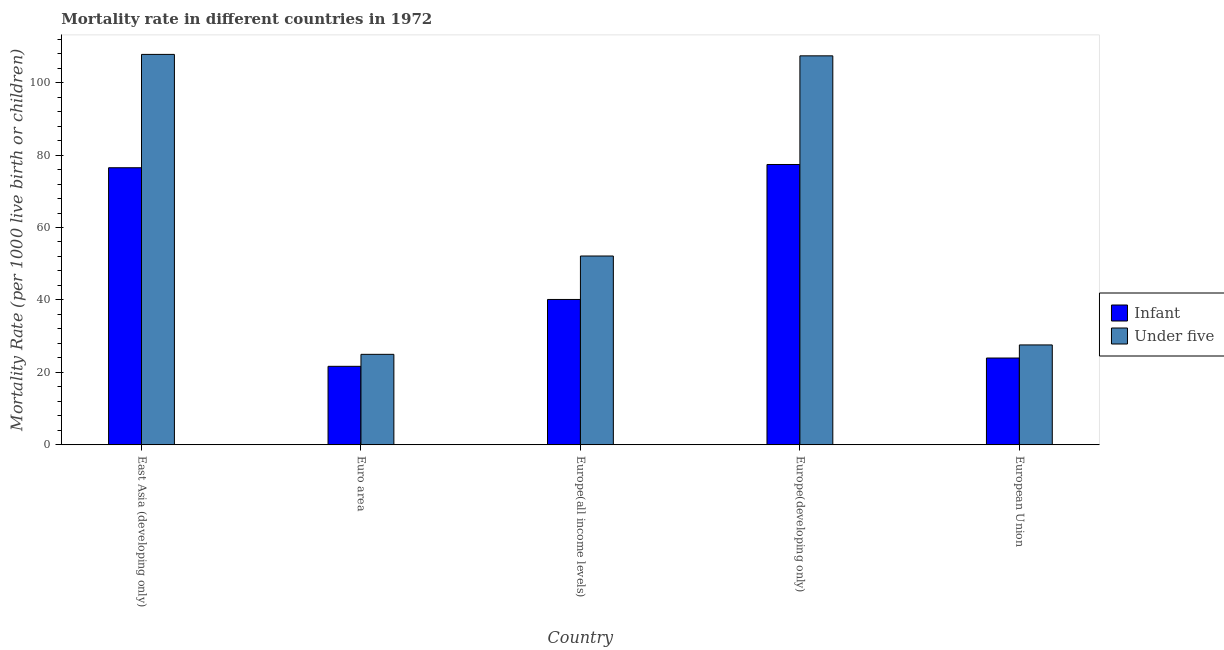How many groups of bars are there?
Offer a terse response. 5. Are the number of bars on each tick of the X-axis equal?
Provide a short and direct response. Yes. How many bars are there on the 3rd tick from the left?
Your answer should be compact. 2. What is the label of the 4th group of bars from the left?
Give a very brief answer. Europe(developing only). What is the infant mortality rate in Europe(developing only)?
Your response must be concise. 77.4. Across all countries, what is the maximum under-5 mortality rate?
Your response must be concise. 107.8. Across all countries, what is the minimum infant mortality rate?
Offer a very short reply. 21.67. In which country was the under-5 mortality rate maximum?
Offer a very short reply. East Asia (developing only). What is the total under-5 mortality rate in the graph?
Give a very brief answer. 319.88. What is the difference between the under-5 mortality rate in Euro area and that in European Union?
Your response must be concise. -2.6. What is the difference between the infant mortality rate in East Asia (developing only) and the under-5 mortality rate in Europe(developing only)?
Your response must be concise. -30.9. What is the average under-5 mortality rate per country?
Keep it short and to the point. 63.98. What is the difference between the infant mortality rate and under-5 mortality rate in East Asia (developing only)?
Offer a terse response. -31.3. What is the ratio of the under-5 mortality rate in Euro area to that in Europe(developing only)?
Your response must be concise. 0.23. Is the under-5 mortality rate in Euro area less than that in Europe(all income levels)?
Your answer should be very brief. Yes. What is the difference between the highest and the second highest under-5 mortality rate?
Make the answer very short. 0.4. What is the difference between the highest and the lowest infant mortality rate?
Make the answer very short. 55.73. Is the sum of the infant mortality rate in East Asia (developing only) and Europe(developing only) greater than the maximum under-5 mortality rate across all countries?
Your response must be concise. Yes. What does the 1st bar from the left in Europe(developing only) represents?
Your response must be concise. Infant. What does the 2nd bar from the right in Euro area represents?
Offer a terse response. Infant. How many bars are there?
Your answer should be compact. 10. Are all the bars in the graph horizontal?
Your answer should be compact. No. Are the values on the major ticks of Y-axis written in scientific E-notation?
Offer a very short reply. No. Does the graph contain any zero values?
Offer a very short reply. No. Where does the legend appear in the graph?
Ensure brevity in your answer.  Center right. How many legend labels are there?
Provide a short and direct response. 2. What is the title of the graph?
Offer a very short reply. Mortality rate in different countries in 1972. What is the label or title of the X-axis?
Provide a succinct answer. Country. What is the label or title of the Y-axis?
Your answer should be compact. Mortality Rate (per 1000 live birth or children). What is the Mortality Rate (per 1000 live birth or children) in Infant in East Asia (developing only)?
Keep it short and to the point. 76.5. What is the Mortality Rate (per 1000 live birth or children) in Under five in East Asia (developing only)?
Offer a very short reply. 107.8. What is the Mortality Rate (per 1000 live birth or children) of Infant in Euro area?
Give a very brief answer. 21.67. What is the Mortality Rate (per 1000 live birth or children) of Under five in Euro area?
Provide a succinct answer. 24.98. What is the Mortality Rate (per 1000 live birth or children) of Infant in Europe(all income levels)?
Your answer should be very brief. 40.13. What is the Mortality Rate (per 1000 live birth or children) of Under five in Europe(all income levels)?
Offer a very short reply. 52.13. What is the Mortality Rate (per 1000 live birth or children) of Infant in Europe(developing only)?
Offer a very short reply. 77.4. What is the Mortality Rate (per 1000 live birth or children) of Under five in Europe(developing only)?
Make the answer very short. 107.4. What is the Mortality Rate (per 1000 live birth or children) of Infant in European Union?
Your answer should be very brief. 23.96. What is the Mortality Rate (per 1000 live birth or children) of Under five in European Union?
Provide a succinct answer. 27.58. Across all countries, what is the maximum Mortality Rate (per 1000 live birth or children) in Infant?
Provide a short and direct response. 77.4. Across all countries, what is the maximum Mortality Rate (per 1000 live birth or children) of Under five?
Keep it short and to the point. 107.8. Across all countries, what is the minimum Mortality Rate (per 1000 live birth or children) in Infant?
Keep it short and to the point. 21.67. Across all countries, what is the minimum Mortality Rate (per 1000 live birth or children) of Under five?
Provide a short and direct response. 24.98. What is the total Mortality Rate (per 1000 live birth or children) in Infant in the graph?
Ensure brevity in your answer.  239.66. What is the total Mortality Rate (per 1000 live birth or children) of Under five in the graph?
Provide a succinct answer. 319.88. What is the difference between the Mortality Rate (per 1000 live birth or children) in Infant in East Asia (developing only) and that in Euro area?
Ensure brevity in your answer.  54.83. What is the difference between the Mortality Rate (per 1000 live birth or children) in Under five in East Asia (developing only) and that in Euro area?
Ensure brevity in your answer.  82.82. What is the difference between the Mortality Rate (per 1000 live birth or children) in Infant in East Asia (developing only) and that in Europe(all income levels)?
Your answer should be compact. 36.37. What is the difference between the Mortality Rate (per 1000 live birth or children) of Under five in East Asia (developing only) and that in Europe(all income levels)?
Provide a succinct answer. 55.67. What is the difference between the Mortality Rate (per 1000 live birth or children) of Under five in East Asia (developing only) and that in Europe(developing only)?
Ensure brevity in your answer.  0.4. What is the difference between the Mortality Rate (per 1000 live birth or children) in Infant in East Asia (developing only) and that in European Union?
Keep it short and to the point. 52.54. What is the difference between the Mortality Rate (per 1000 live birth or children) in Under five in East Asia (developing only) and that in European Union?
Offer a very short reply. 80.22. What is the difference between the Mortality Rate (per 1000 live birth or children) of Infant in Euro area and that in Europe(all income levels)?
Your answer should be compact. -18.46. What is the difference between the Mortality Rate (per 1000 live birth or children) of Under five in Euro area and that in Europe(all income levels)?
Make the answer very short. -27.15. What is the difference between the Mortality Rate (per 1000 live birth or children) of Infant in Euro area and that in Europe(developing only)?
Offer a very short reply. -55.73. What is the difference between the Mortality Rate (per 1000 live birth or children) in Under five in Euro area and that in Europe(developing only)?
Offer a very short reply. -82.42. What is the difference between the Mortality Rate (per 1000 live birth or children) of Infant in Euro area and that in European Union?
Your answer should be very brief. -2.29. What is the difference between the Mortality Rate (per 1000 live birth or children) in Under five in Euro area and that in European Union?
Offer a very short reply. -2.6. What is the difference between the Mortality Rate (per 1000 live birth or children) of Infant in Europe(all income levels) and that in Europe(developing only)?
Provide a succinct answer. -37.27. What is the difference between the Mortality Rate (per 1000 live birth or children) of Under five in Europe(all income levels) and that in Europe(developing only)?
Your answer should be compact. -55.27. What is the difference between the Mortality Rate (per 1000 live birth or children) of Infant in Europe(all income levels) and that in European Union?
Provide a short and direct response. 16.17. What is the difference between the Mortality Rate (per 1000 live birth or children) of Under five in Europe(all income levels) and that in European Union?
Keep it short and to the point. 24.55. What is the difference between the Mortality Rate (per 1000 live birth or children) of Infant in Europe(developing only) and that in European Union?
Your answer should be compact. 53.44. What is the difference between the Mortality Rate (per 1000 live birth or children) of Under five in Europe(developing only) and that in European Union?
Provide a succinct answer. 79.82. What is the difference between the Mortality Rate (per 1000 live birth or children) in Infant in East Asia (developing only) and the Mortality Rate (per 1000 live birth or children) in Under five in Euro area?
Offer a terse response. 51.52. What is the difference between the Mortality Rate (per 1000 live birth or children) in Infant in East Asia (developing only) and the Mortality Rate (per 1000 live birth or children) in Under five in Europe(all income levels)?
Your answer should be very brief. 24.37. What is the difference between the Mortality Rate (per 1000 live birth or children) of Infant in East Asia (developing only) and the Mortality Rate (per 1000 live birth or children) of Under five in Europe(developing only)?
Make the answer very short. -30.9. What is the difference between the Mortality Rate (per 1000 live birth or children) of Infant in East Asia (developing only) and the Mortality Rate (per 1000 live birth or children) of Under five in European Union?
Your answer should be very brief. 48.92. What is the difference between the Mortality Rate (per 1000 live birth or children) of Infant in Euro area and the Mortality Rate (per 1000 live birth or children) of Under five in Europe(all income levels)?
Your response must be concise. -30.46. What is the difference between the Mortality Rate (per 1000 live birth or children) in Infant in Euro area and the Mortality Rate (per 1000 live birth or children) in Under five in Europe(developing only)?
Your response must be concise. -85.73. What is the difference between the Mortality Rate (per 1000 live birth or children) of Infant in Euro area and the Mortality Rate (per 1000 live birth or children) of Under five in European Union?
Your response must be concise. -5.91. What is the difference between the Mortality Rate (per 1000 live birth or children) of Infant in Europe(all income levels) and the Mortality Rate (per 1000 live birth or children) of Under five in Europe(developing only)?
Your answer should be compact. -67.27. What is the difference between the Mortality Rate (per 1000 live birth or children) in Infant in Europe(all income levels) and the Mortality Rate (per 1000 live birth or children) in Under five in European Union?
Provide a succinct answer. 12.55. What is the difference between the Mortality Rate (per 1000 live birth or children) in Infant in Europe(developing only) and the Mortality Rate (per 1000 live birth or children) in Under five in European Union?
Keep it short and to the point. 49.82. What is the average Mortality Rate (per 1000 live birth or children) in Infant per country?
Keep it short and to the point. 47.93. What is the average Mortality Rate (per 1000 live birth or children) of Under five per country?
Provide a succinct answer. 63.98. What is the difference between the Mortality Rate (per 1000 live birth or children) in Infant and Mortality Rate (per 1000 live birth or children) in Under five in East Asia (developing only)?
Make the answer very short. -31.3. What is the difference between the Mortality Rate (per 1000 live birth or children) of Infant and Mortality Rate (per 1000 live birth or children) of Under five in Euro area?
Ensure brevity in your answer.  -3.31. What is the difference between the Mortality Rate (per 1000 live birth or children) of Infant and Mortality Rate (per 1000 live birth or children) of Under five in Europe(all income levels)?
Offer a very short reply. -12. What is the difference between the Mortality Rate (per 1000 live birth or children) of Infant and Mortality Rate (per 1000 live birth or children) of Under five in European Union?
Make the answer very short. -3.62. What is the ratio of the Mortality Rate (per 1000 live birth or children) in Infant in East Asia (developing only) to that in Euro area?
Offer a terse response. 3.53. What is the ratio of the Mortality Rate (per 1000 live birth or children) of Under five in East Asia (developing only) to that in Euro area?
Provide a succinct answer. 4.32. What is the ratio of the Mortality Rate (per 1000 live birth or children) in Infant in East Asia (developing only) to that in Europe(all income levels)?
Provide a short and direct response. 1.91. What is the ratio of the Mortality Rate (per 1000 live birth or children) in Under five in East Asia (developing only) to that in Europe(all income levels)?
Ensure brevity in your answer.  2.07. What is the ratio of the Mortality Rate (per 1000 live birth or children) of Infant in East Asia (developing only) to that in Europe(developing only)?
Provide a short and direct response. 0.99. What is the ratio of the Mortality Rate (per 1000 live birth or children) in Under five in East Asia (developing only) to that in Europe(developing only)?
Provide a short and direct response. 1. What is the ratio of the Mortality Rate (per 1000 live birth or children) in Infant in East Asia (developing only) to that in European Union?
Make the answer very short. 3.19. What is the ratio of the Mortality Rate (per 1000 live birth or children) of Under five in East Asia (developing only) to that in European Union?
Make the answer very short. 3.91. What is the ratio of the Mortality Rate (per 1000 live birth or children) in Infant in Euro area to that in Europe(all income levels)?
Your response must be concise. 0.54. What is the ratio of the Mortality Rate (per 1000 live birth or children) in Under five in Euro area to that in Europe(all income levels)?
Offer a very short reply. 0.48. What is the ratio of the Mortality Rate (per 1000 live birth or children) of Infant in Euro area to that in Europe(developing only)?
Your answer should be very brief. 0.28. What is the ratio of the Mortality Rate (per 1000 live birth or children) of Under five in Euro area to that in Europe(developing only)?
Ensure brevity in your answer.  0.23. What is the ratio of the Mortality Rate (per 1000 live birth or children) of Infant in Euro area to that in European Union?
Your answer should be very brief. 0.9. What is the ratio of the Mortality Rate (per 1000 live birth or children) in Under five in Euro area to that in European Union?
Offer a very short reply. 0.91. What is the ratio of the Mortality Rate (per 1000 live birth or children) in Infant in Europe(all income levels) to that in Europe(developing only)?
Your answer should be compact. 0.52. What is the ratio of the Mortality Rate (per 1000 live birth or children) in Under five in Europe(all income levels) to that in Europe(developing only)?
Your response must be concise. 0.49. What is the ratio of the Mortality Rate (per 1000 live birth or children) of Infant in Europe(all income levels) to that in European Union?
Your answer should be very brief. 1.67. What is the ratio of the Mortality Rate (per 1000 live birth or children) of Under five in Europe(all income levels) to that in European Union?
Provide a succinct answer. 1.89. What is the ratio of the Mortality Rate (per 1000 live birth or children) of Infant in Europe(developing only) to that in European Union?
Your response must be concise. 3.23. What is the ratio of the Mortality Rate (per 1000 live birth or children) of Under five in Europe(developing only) to that in European Union?
Your response must be concise. 3.89. What is the difference between the highest and the lowest Mortality Rate (per 1000 live birth or children) in Infant?
Your answer should be very brief. 55.73. What is the difference between the highest and the lowest Mortality Rate (per 1000 live birth or children) of Under five?
Provide a succinct answer. 82.82. 